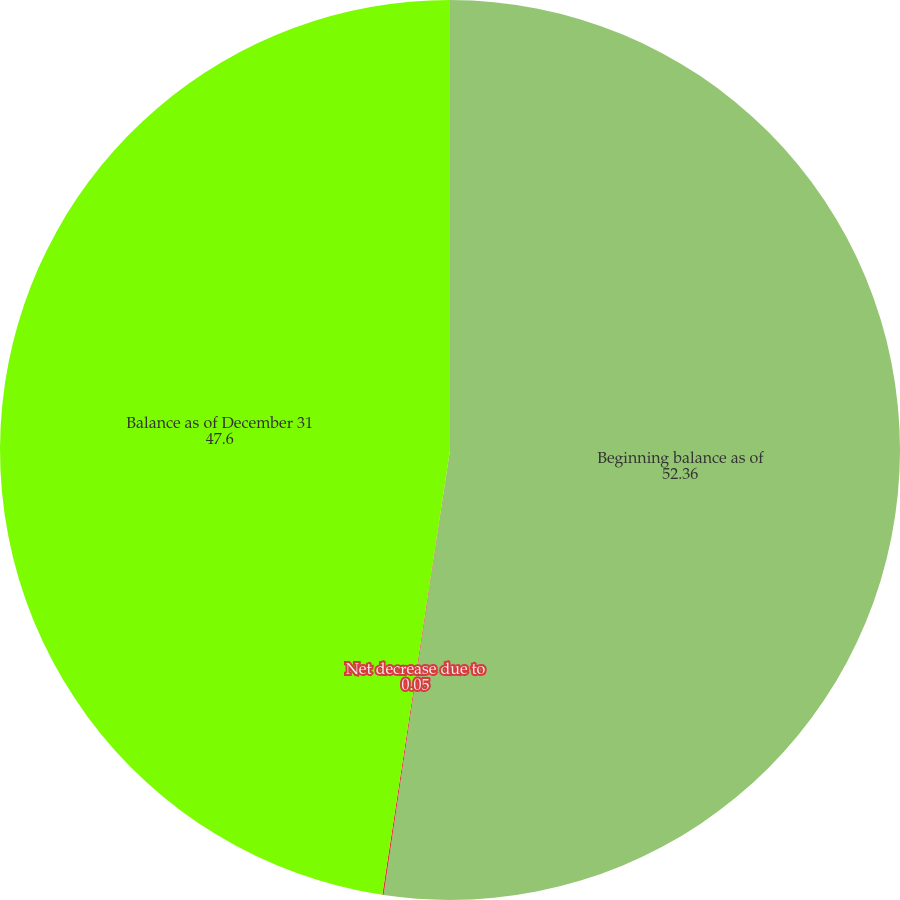<chart> <loc_0><loc_0><loc_500><loc_500><pie_chart><fcel>Beginning balance as of<fcel>Net decrease due to<fcel>Balance as of December 31<nl><fcel>52.36%<fcel>0.05%<fcel>47.6%<nl></chart> 